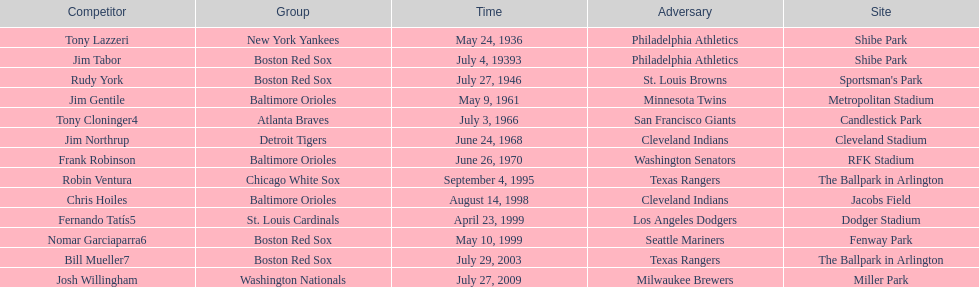What is the number of times a boston red sox player has had two grand slams in one game? 4. 